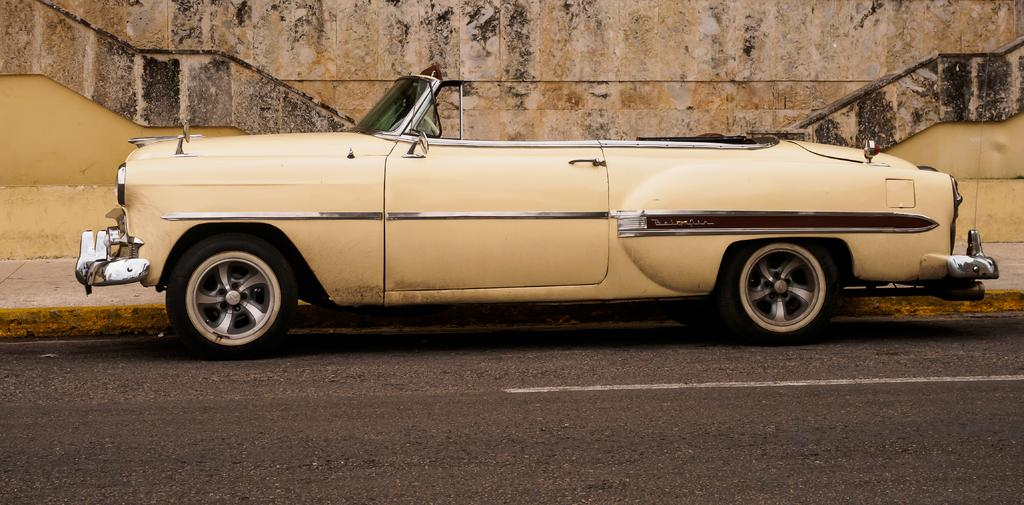What is the main subject of the image? There is a car in the image. Where is the car located? The car is on the road. What can be seen in the background of the image? There is a building and a staircase in the background of the image. What type of location is depicted in the image? The image is taken on the road. What type of art can be seen hanging on the walls in the room in the image? There is no room present in the image; it is taken on the road and features a car, a building, and a staircase in the background. 